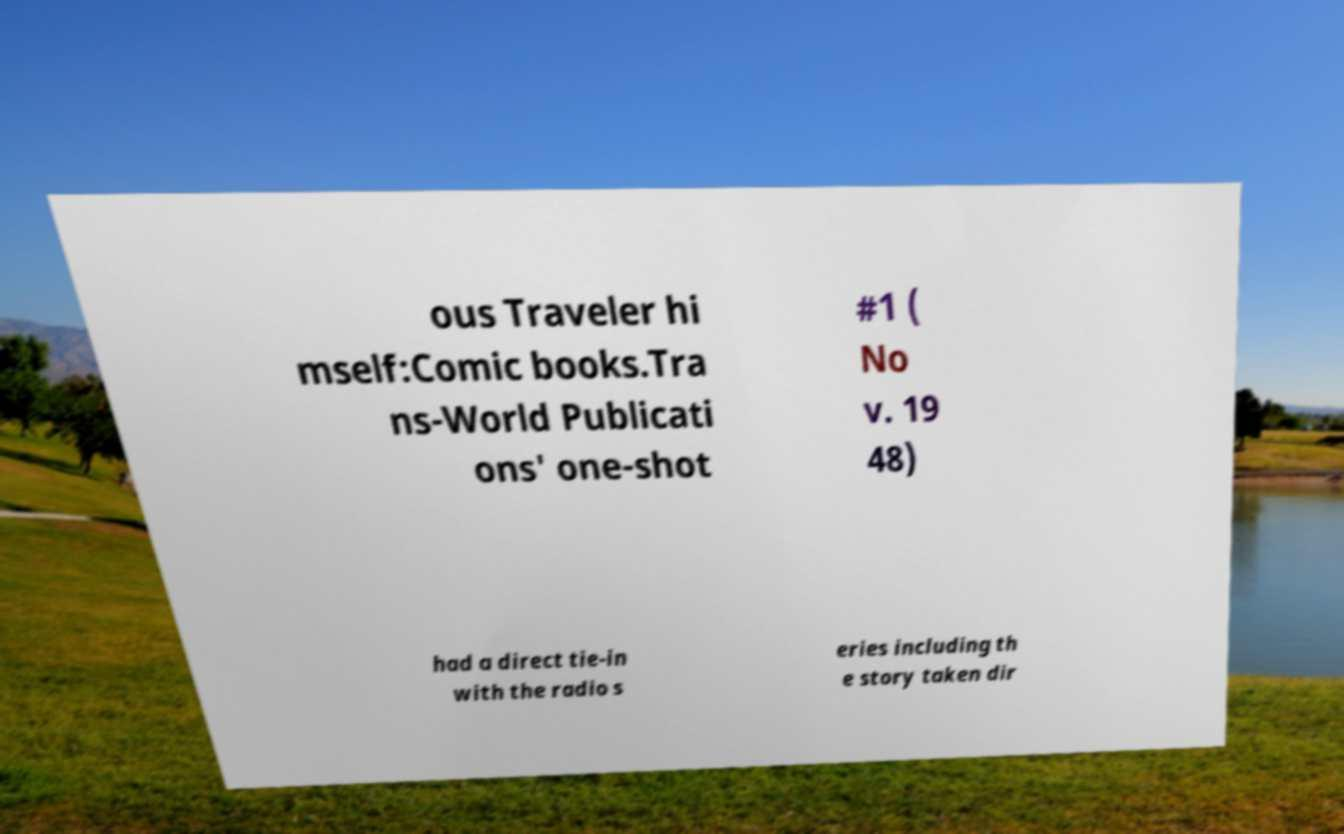Can you accurately transcribe the text from the provided image for me? ous Traveler hi mself:Comic books.Tra ns-World Publicati ons' one-shot #1 ( No v. 19 48) had a direct tie-in with the radio s eries including th e story taken dir 